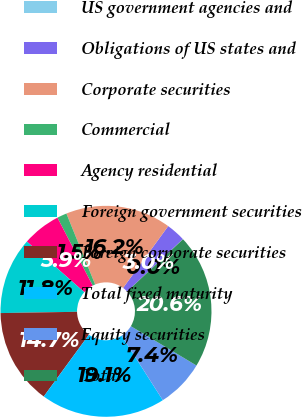<chart> <loc_0><loc_0><loc_500><loc_500><pie_chart><fcel>US government agencies and<fcel>Obligations of US states and<fcel>Corporate securities<fcel>Commercial<fcel>Agency residential<fcel>Foreign government securities<fcel>Foreign corporate securities<fcel>Total fixed maturity<fcel>Equity securities<fcel>Total<nl><fcel>0.03%<fcel>2.96%<fcel>16.16%<fcel>1.49%<fcel>5.89%<fcel>11.76%<fcel>14.69%<fcel>19.09%<fcel>7.36%<fcel>20.56%<nl></chart> 